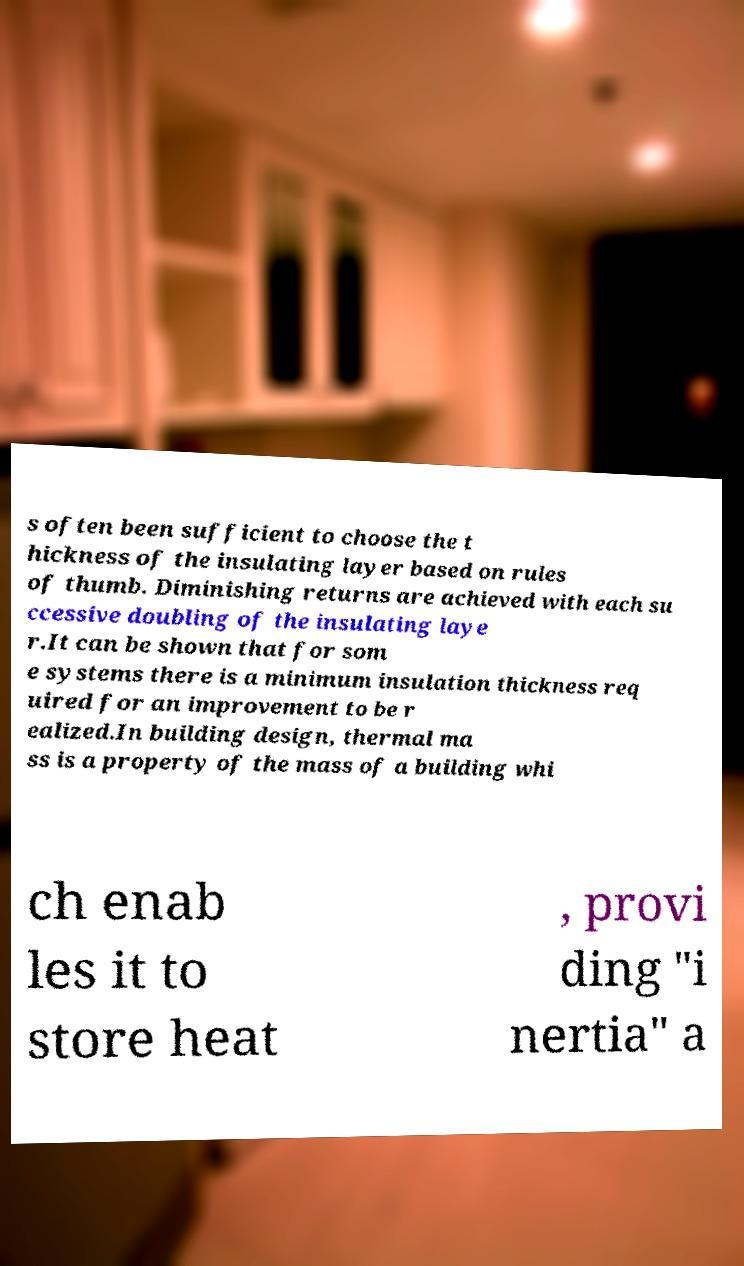I need the written content from this picture converted into text. Can you do that? s often been sufficient to choose the t hickness of the insulating layer based on rules of thumb. Diminishing returns are achieved with each su ccessive doubling of the insulating laye r.It can be shown that for som e systems there is a minimum insulation thickness req uired for an improvement to be r ealized.In building design, thermal ma ss is a property of the mass of a building whi ch enab les it to store heat , provi ding "i nertia" a 